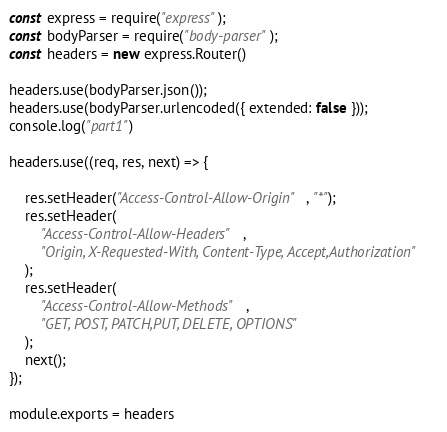Convert code to text. <code><loc_0><loc_0><loc_500><loc_500><_JavaScript_>const express = require("express");
const bodyParser = require("body-parser");
const headers = new express.Router()

headers.use(bodyParser.json());
headers.use(bodyParser.urlencoded({ extended: false }));
console.log("part1")

headers.use((req, res, next) => {
   
    res.setHeader("Access-Control-Allow-Origin", "*");
    res.setHeader(
        "Access-Control-Allow-Headers",
        "Origin, X-Requested-With, Content-Type, Accept,Authorization"
    );
    res.setHeader(
        "Access-Control-Allow-Methods",
        "GET, POST, PATCH,PUT, DELETE, OPTIONS"
    );
    next();
});

module.exports = headers</code> 